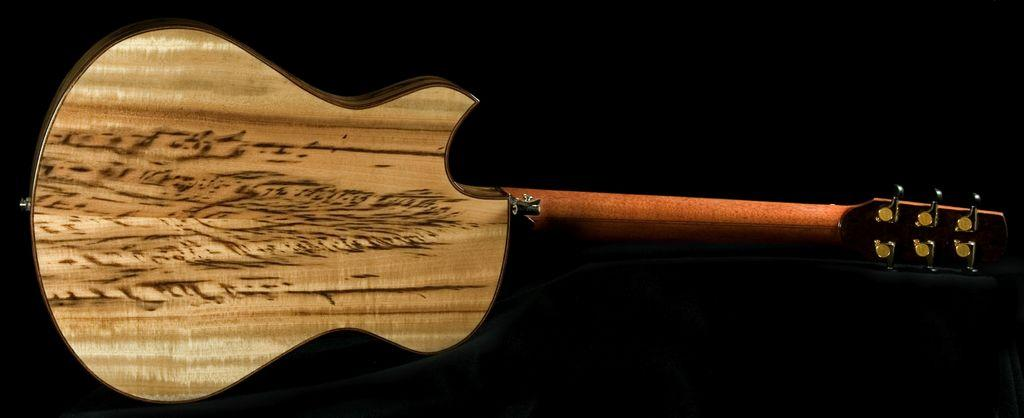What musical instrument is present in the image? There is a guitar in the image. What type of ticket is required to play the guitar in the image? There is no ticket or any indication of a requirement for a ticket in the image; it simply features a guitar. What type of pan can be seen being used to cook a meal in the image? There is no pan or any indication of cooking in the image; it only features a guitar. 